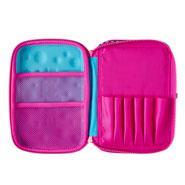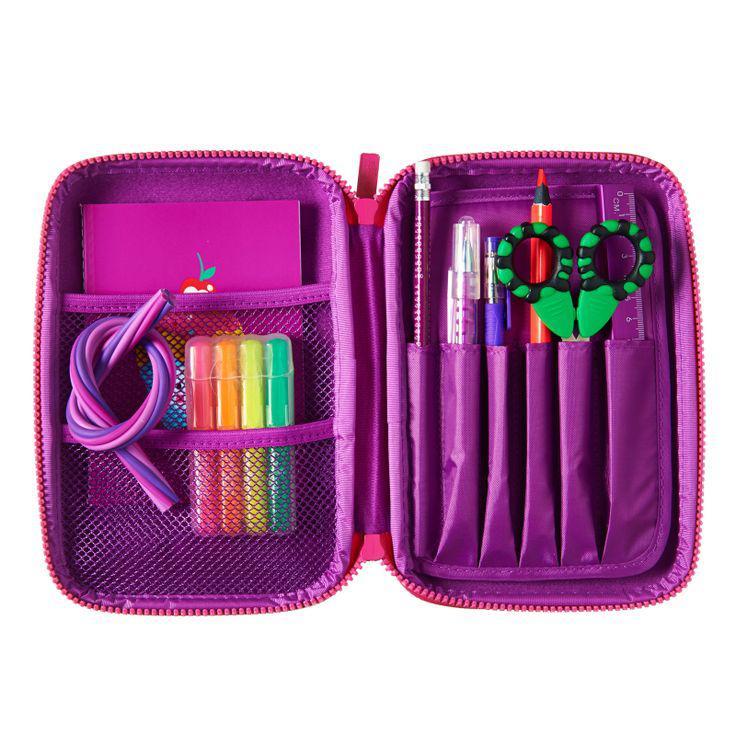The first image is the image on the left, the second image is the image on the right. For the images shown, is this caption "A pair of scissors is in the pencil pouch next to a pencil." true? Answer yes or no. Yes. The first image is the image on the left, the second image is the image on the right. Considering the images on both sides, is "One of the containers contains a pair of scissors." valid? Answer yes or no. Yes. 